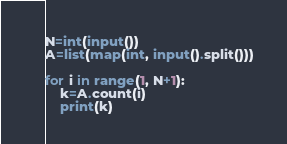<code> <loc_0><loc_0><loc_500><loc_500><_Python_>N=int(input())
A=list(map(int, input().split()))

for i in range(1, N+1):
    k=A.count(i)
    print(k)</code> 